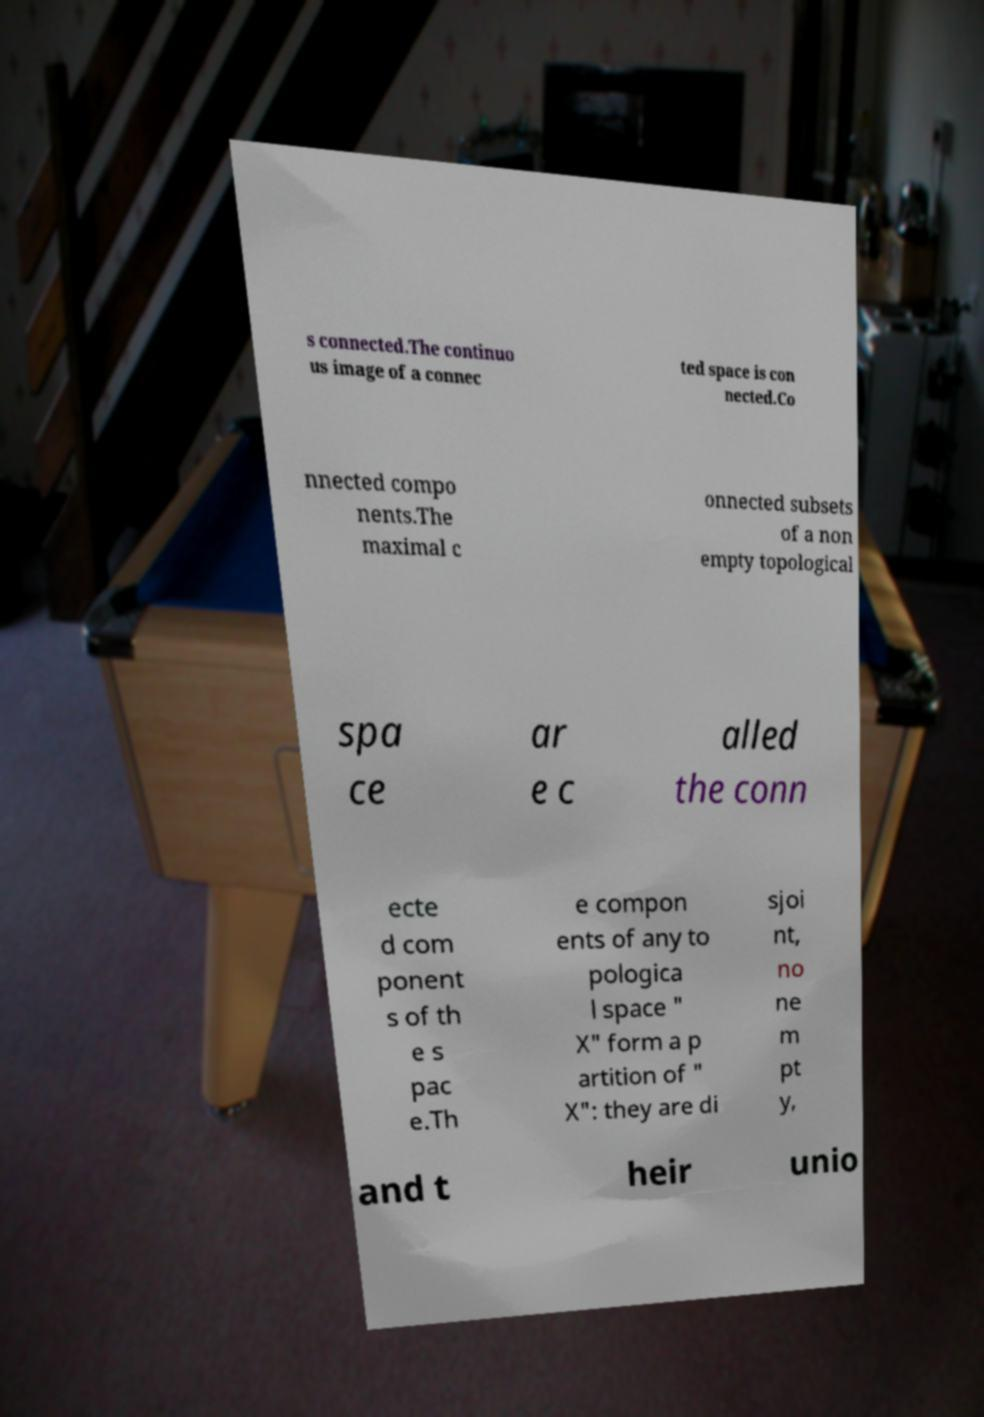I need the written content from this picture converted into text. Can you do that? s connected.The continuo us image of a connec ted space is con nected.Co nnected compo nents.The maximal c onnected subsets of a non empty topological spa ce ar e c alled the conn ecte d com ponent s of th e s pac e.Th e compon ents of any to pologica l space " X" form a p artition of " X": they are di sjoi nt, no ne m pt y, and t heir unio 